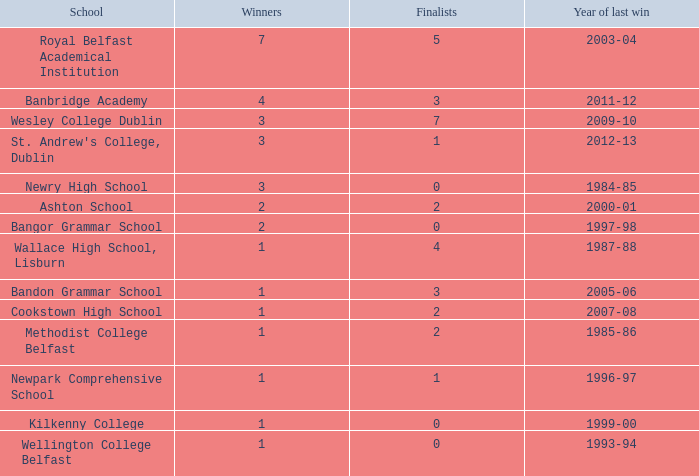Could you help me parse every detail presented in this table? {'header': ['School', 'Winners', 'Finalists', 'Year of last win'], 'rows': [['Royal Belfast Academical Institution', '7', '5', '2003-04'], ['Banbridge Academy', '4', '3', '2011-12'], ['Wesley College Dublin', '3', '7', '2009-10'], ["St. Andrew's College, Dublin", '3', '1', '2012-13'], ['Newry High School', '3', '0', '1984-85'], ['Ashton School', '2', '2', '2000-01'], ['Bangor Grammar School', '2', '0', '1997-98'], ['Wallace High School, Lisburn', '1', '4', '1987-88'], ['Bandon Grammar School', '1', '3', '2005-06'], ['Cookstown High School', '1', '2', '2007-08'], ['Methodist College Belfast', '1', '2', '1985-86'], ['Newpark Comprehensive School', '1', '1', '1996-97'], ['Kilkenny College', '1', '0', '1999-00'], ['Wellington College Belfast', '1', '0', '1993-94']]} What was the total number of finals when the most recent victory occurred in the 2012-13 season? 4.0. 